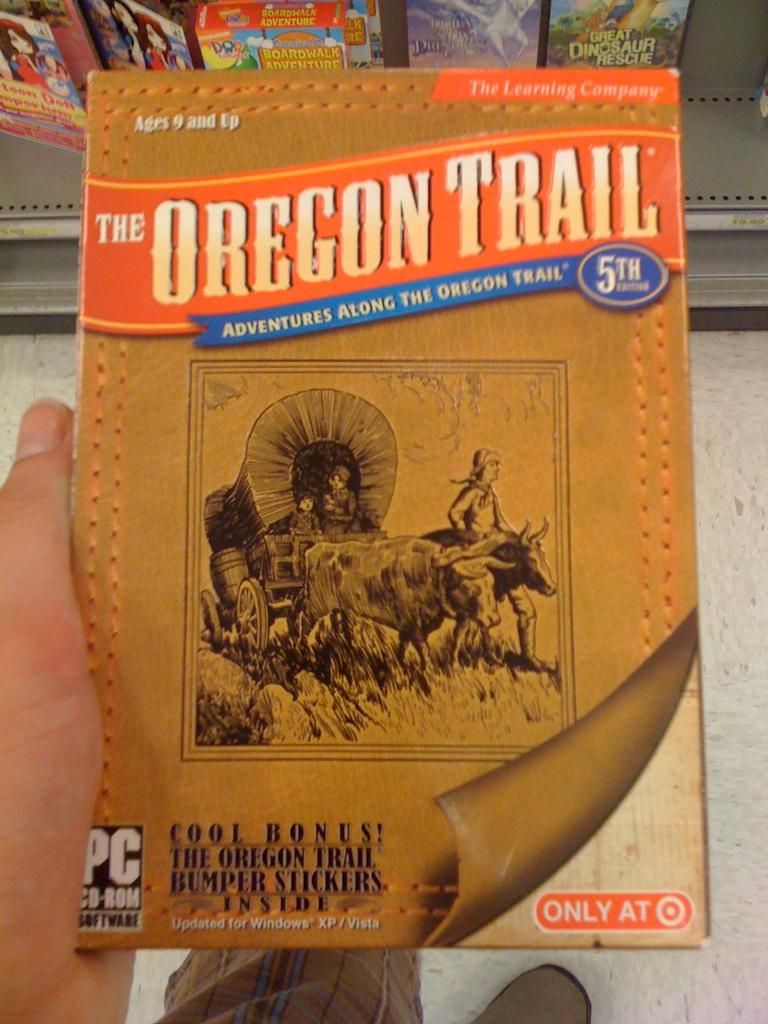<image>
Offer a succinct explanation of the picture presented. A computer game is titled The Oregon Trail and has a picture of a wagon being pulled on it. 